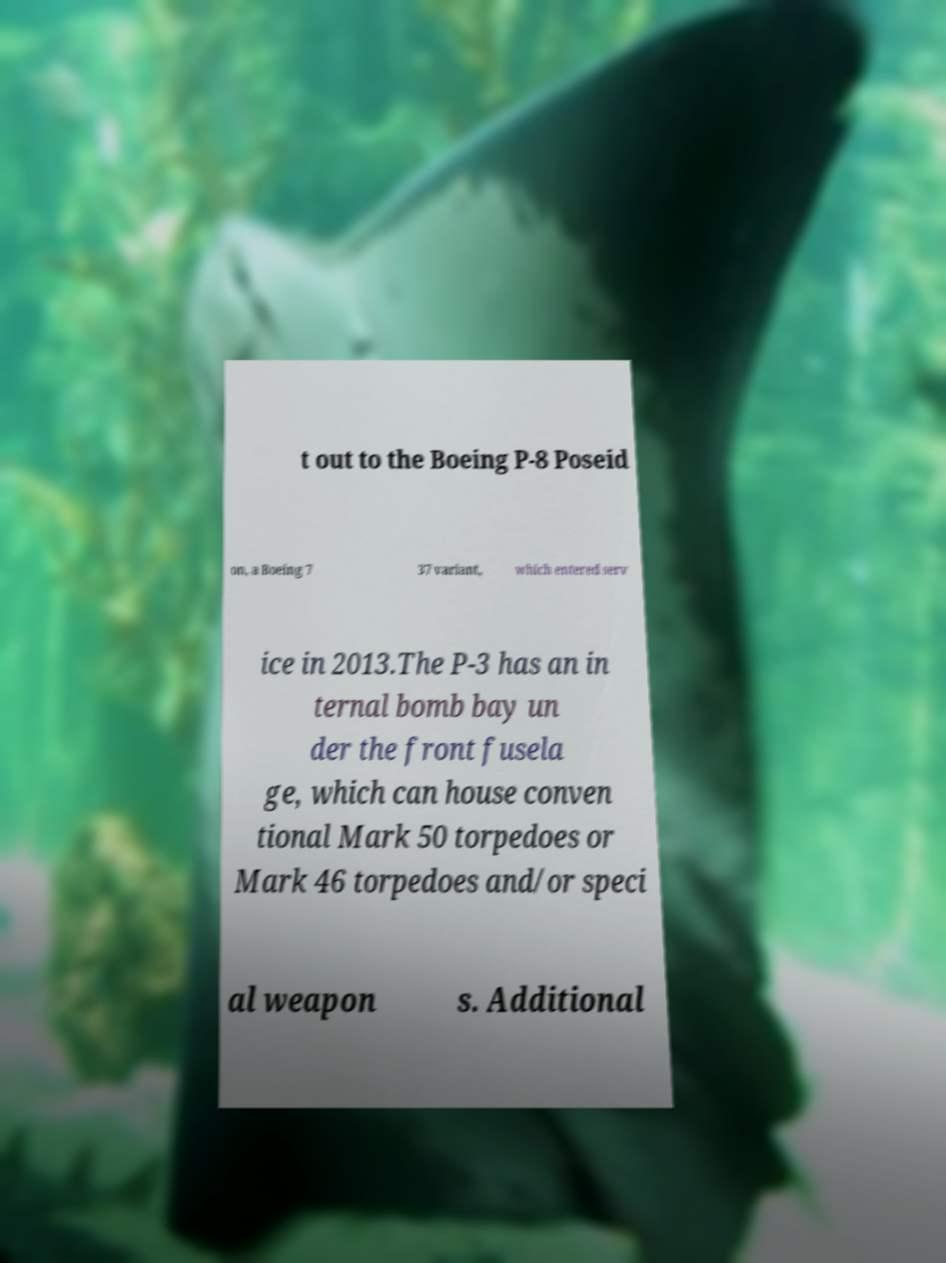I need the written content from this picture converted into text. Can you do that? t out to the Boeing P-8 Poseid on, a Boeing 7 37 variant, which entered serv ice in 2013.The P-3 has an in ternal bomb bay un der the front fusela ge, which can house conven tional Mark 50 torpedoes or Mark 46 torpedoes and/or speci al weapon s. Additional 